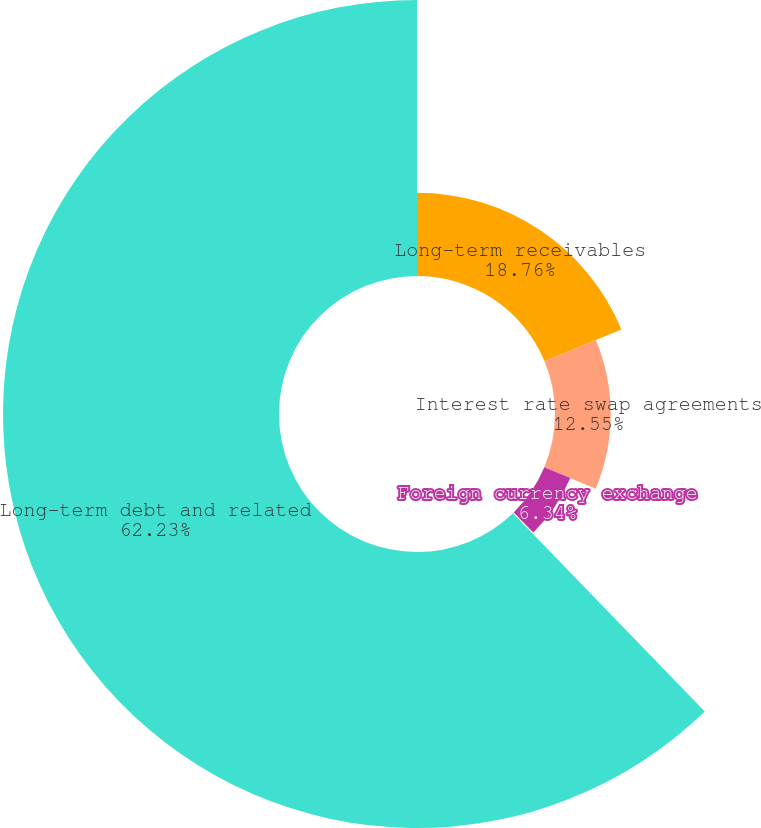Convert chart to OTSL. <chart><loc_0><loc_0><loc_500><loc_500><pie_chart><fcel>Long-term receivables<fcel>Interest rate swap agreements<fcel>Foreign currency exchange<fcel>Forward commodity contracts<fcel>Long-term debt and related<nl><fcel>18.76%<fcel>12.55%<fcel>6.34%<fcel>0.12%<fcel>62.24%<nl></chart> 